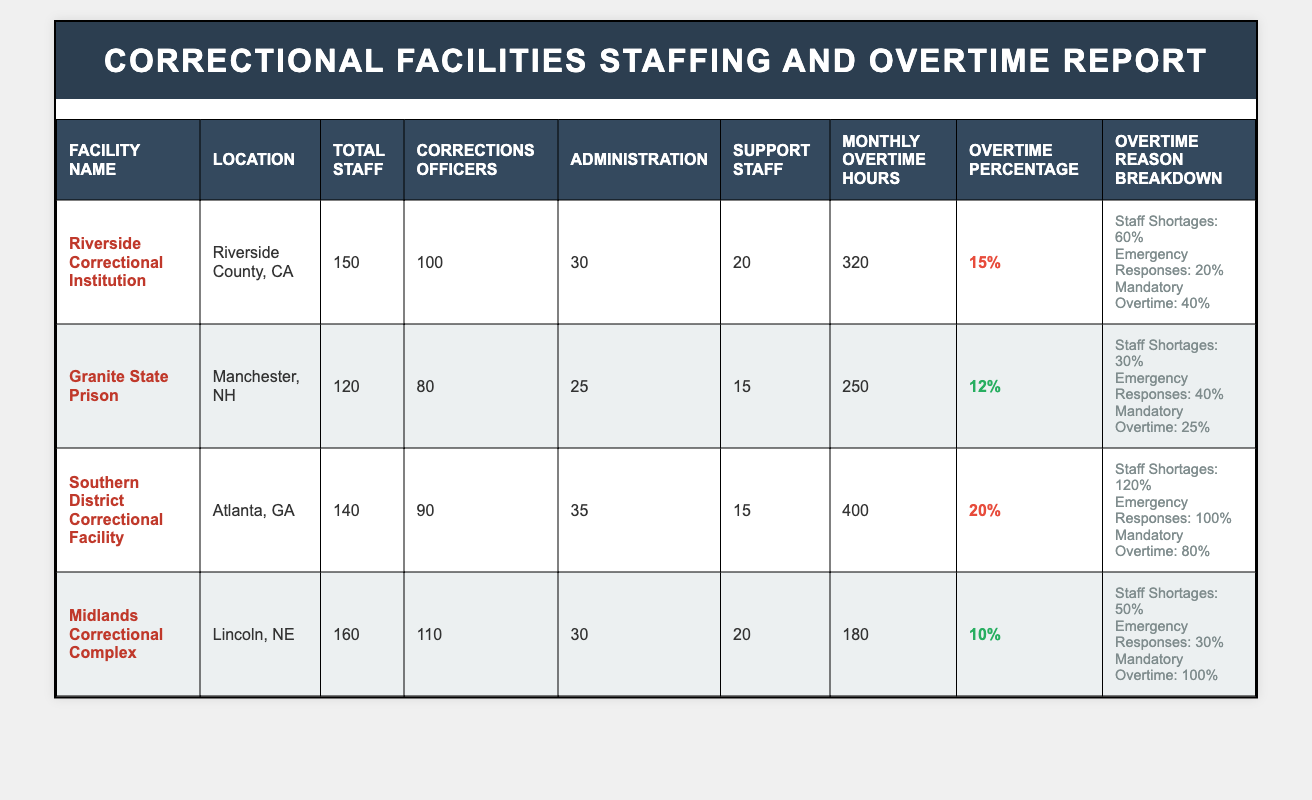What is the total staff count at the Southern District Correctional Facility? The Southern District Correctional Facility's total staff count is listed directly in the table. It states that the total staff is 140.
Answer: 140 How many corrections officers are at the Riverside Correctional Institution? The table provides the count of corrections officers specifically for the Riverside Correctional Institution, which is 100.
Answer: 100 What is the average monthly overtime hours across all facilities? To find the average, add the monthly averages for all facilities: 320 (Riverside) + 250 (Granite) + 400 (Southern) + 180 (Midlands) = 1150. There are four facilities, so the average is 1150/4 = 287.5.
Answer: 287.5 Is the percentage of overtime hours at Granite State Prison higher than at Midlands Correctional Complex? The overtime percentage for Granite State Prison is 12%, and for Midlands Correctional Complex, it is 10%. Since 12% is greater than 10%, the statement is true.
Answer: Yes Which facility has the highest monthly overtime hours, and what is that number? By reviewing the monthly average overtime hours, the Southern District Correctional Facility shows the highest number at 400 hours.
Answer: 400 What is the total percentage of overtime hours due to staff shortages at the Southern District Correctional Facility? The table specifies that for the Southern District Correctional Facility, staff shortages account for 120% of the reasons for overtime hours. This reflects the high demand and insufficient staff.
Answer: 120% How many total staff does the Granite State Prison have compared to the total staff of the Riverside Correctional Institution? Granite State Prison has 120 total staff, while Riverside Correctional Institution has 150 total staff. Comparing these numbers, Riverside has 30 more total staff than Granite.
Answer: 30 more What is the total overtime percentage across all facilities? The total overtime percentage cannot be simply summed as they represent different staffing sizes. Instead, we consider the monthly averages: the sum is 15% (Riverside) + 12% (Granite) + 20% (Southern) + 10% (Midlands) = 57%. Since there are four facilities, we find an average of 57/4 = 14.25%.
Answer: 14.25% Does the total personnel count at Midlands Correctional Complex exceed the combined total staff of Riverside Correctional Institution and Granite State Prison? The data states that Midlands has 160 staff. Riverside has 150 and Granite has 120; combined, they total 270 (150 + 120). Therefore, Midlands at 160 does not exceed the combined count.
Answer: No 